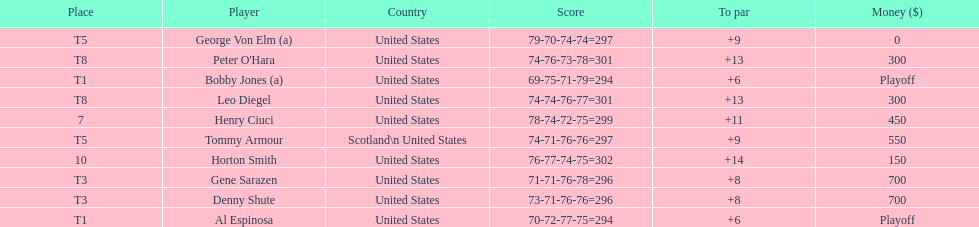What was al espinosa's total stroke count at the final of the 1929 us open? 294. 